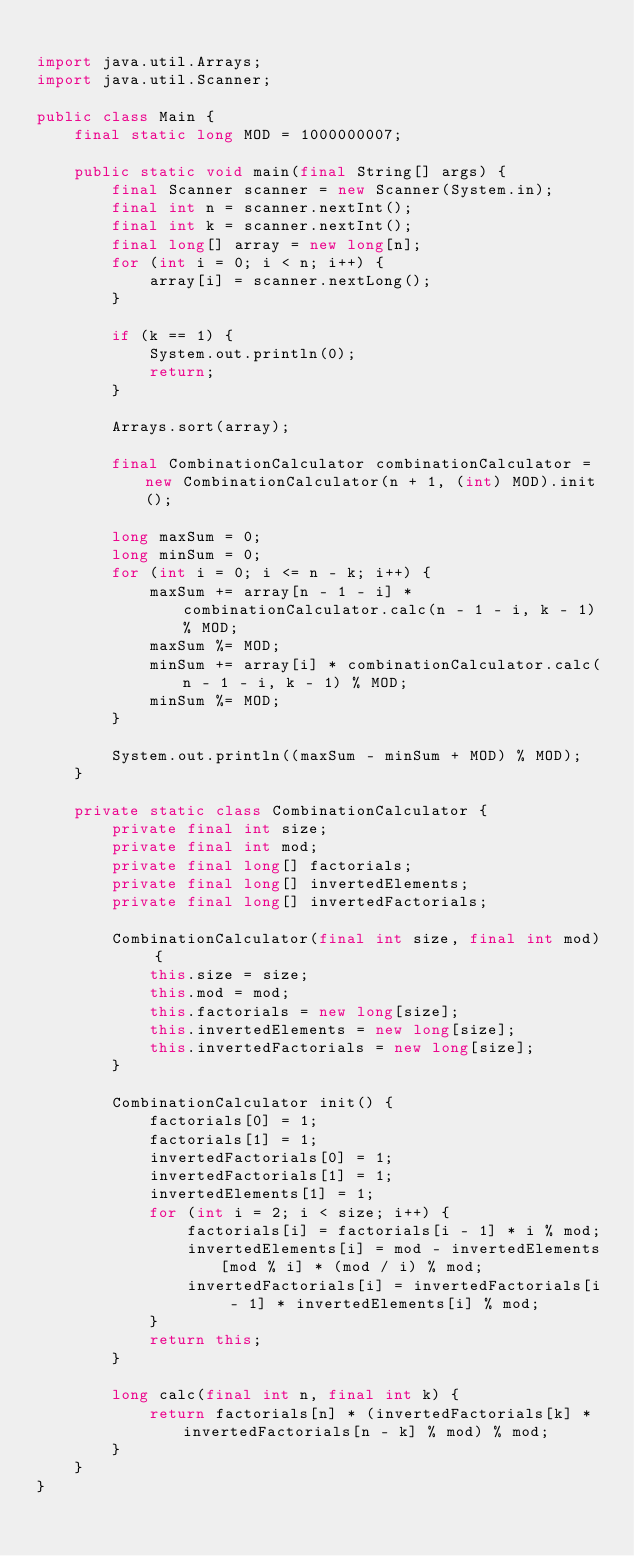<code> <loc_0><loc_0><loc_500><loc_500><_Java_>
import java.util.Arrays;
import java.util.Scanner;

public class Main {
    final static long MOD = 1000000007;

    public static void main(final String[] args) {
        final Scanner scanner = new Scanner(System.in);
        final int n = scanner.nextInt();
        final int k = scanner.nextInt();
        final long[] array = new long[n];
        for (int i = 0; i < n; i++) {
            array[i] = scanner.nextLong();
        }

        if (k == 1) {
            System.out.println(0);
            return;
        }

        Arrays.sort(array);

        final CombinationCalculator combinationCalculator = new CombinationCalculator(n + 1, (int) MOD).init();

        long maxSum = 0;
        long minSum = 0;
        for (int i = 0; i <= n - k; i++) {
            maxSum += array[n - 1 - i] * combinationCalculator.calc(n - 1 - i, k - 1) % MOD;
            maxSum %= MOD;
            minSum += array[i] * combinationCalculator.calc(n - 1 - i, k - 1) % MOD;
            minSum %= MOD;
        }

        System.out.println((maxSum - minSum + MOD) % MOD);
    }

    private static class CombinationCalculator {
        private final int size;
        private final int mod;
        private final long[] factorials;
        private final long[] invertedElements;
        private final long[] invertedFactorials;

        CombinationCalculator(final int size, final int mod) {
            this.size = size;
            this.mod = mod;
            this.factorials = new long[size];
            this.invertedElements = new long[size];
            this.invertedFactorials = new long[size];
        }

        CombinationCalculator init() {
            factorials[0] = 1;
            factorials[1] = 1;
            invertedFactorials[0] = 1;
            invertedFactorials[1] = 1;
            invertedElements[1] = 1;
            for (int i = 2; i < size; i++) {
                factorials[i] = factorials[i - 1] * i % mod;
                invertedElements[i] = mod - invertedElements[mod % i] * (mod / i) % mod;
                invertedFactorials[i] = invertedFactorials[i - 1] * invertedElements[i] % mod;
            }
            return this;
        }

        long calc(final int n, final int k) {
            return factorials[n] * (invertedFactorials[k] * invertedFactorials[n - k] % mod) % mod;
        }
    }
}
</code> 